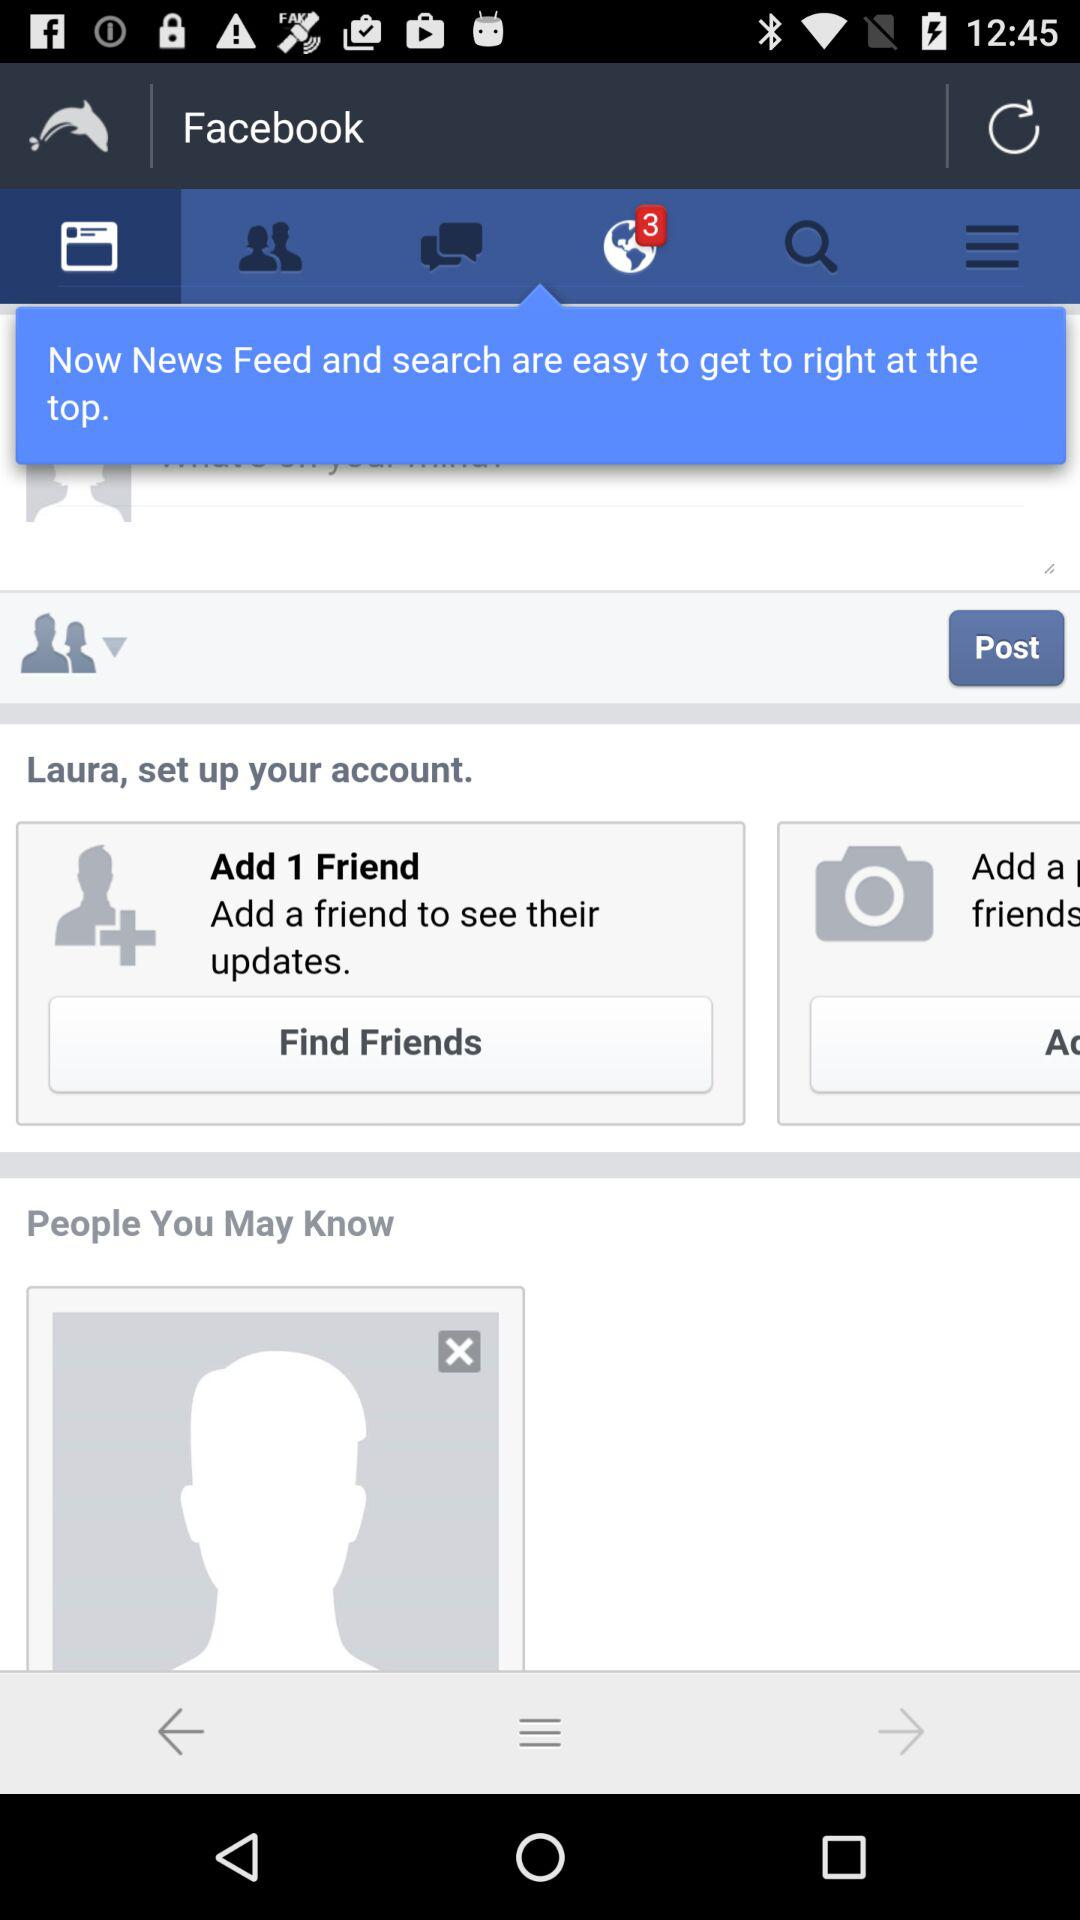What is the number of new notifications? The number of new notifications is 3. 